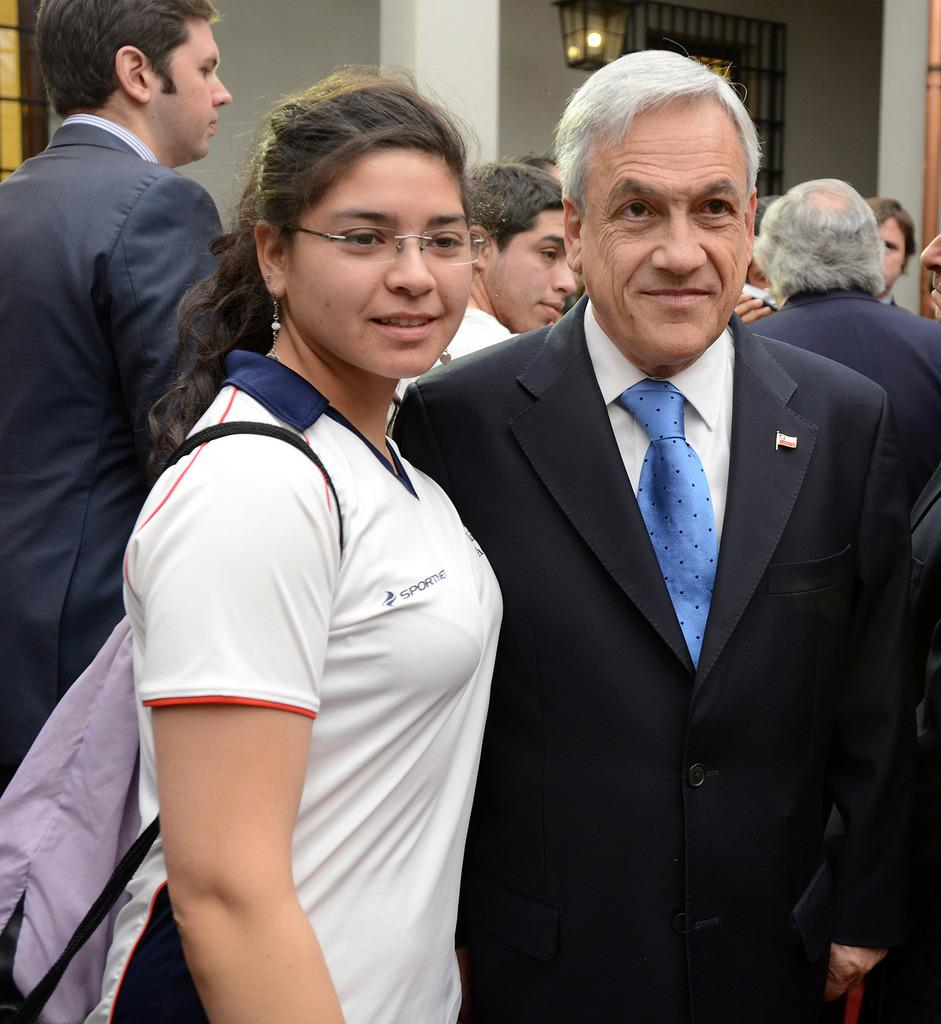How many people are in the foreground of the image? There are two persons standing in the foreground of the image. What can be seen in the background of the image? There is a group of people, a house, and a wall in the background of the image. Can you describe the lighting in the image? There is light visible in the image. What type of brush is being used by the laborer in the image? There is no laborer or brush present in the image. What is the group of people in the background of the image afraid of? There is no indication of fear in the image; the group of people in the background is simply present. 